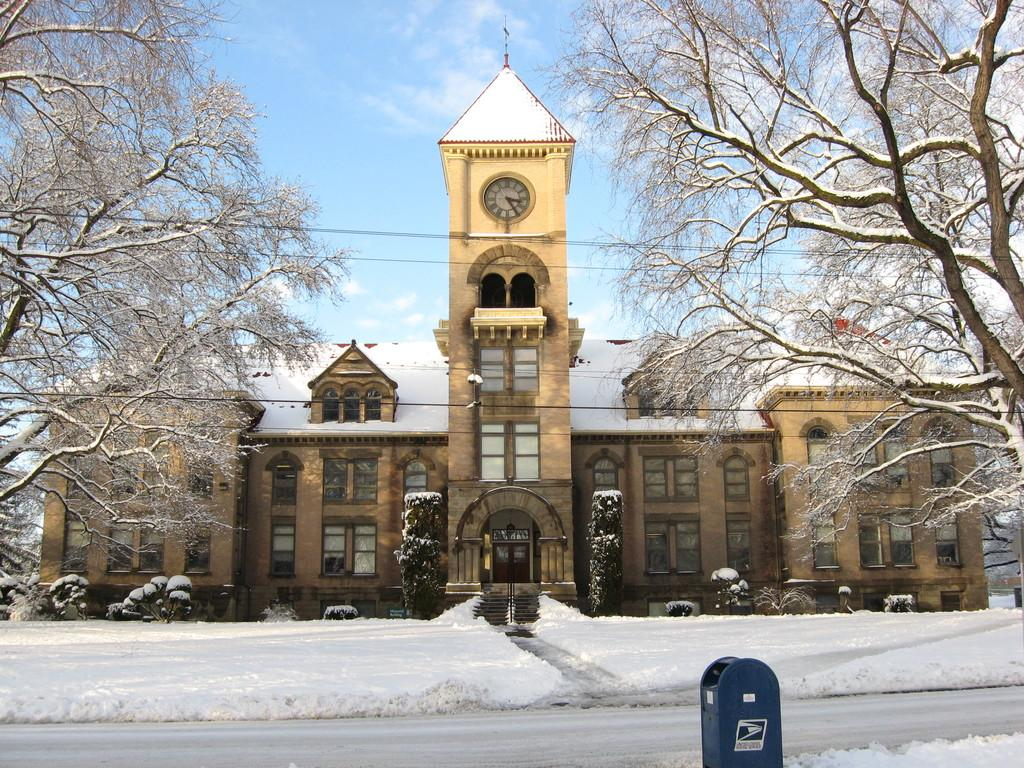What is the condition of the road in the image? The road is covered with snow in the image. What object can be seen for mail delivery? There is a letter box in the image. What type of natural elements are present in the image? Trees and plants are present in the image. What architectural feature is visible in the image? There is a house with a clock in the center. What is the weather like in the image? The sky in the background is cloudy. Can you tell me how many trees are in the school in the image? There is no school present in the image, and therefore no trees within a school can be observed. What happens to the wires when they burst in the image? There is no indication of any wires bursting in the image. 